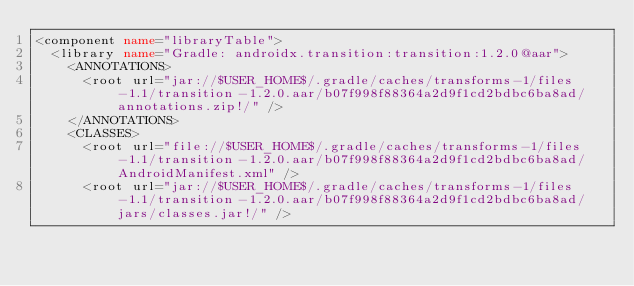<code> <loc_0><loc_0><loc_500><loc_500><_XML_><component name="libraryTable">
  <library name="Gradle: androidx.transition:transition:1.2.0@aar">
    <ANNOTATIONS>
      <root url="jar://$USER_HOME$/.gradle/caches/transforms-1/files-1.1/transition-1.2.0.aar/b07f998f88364a2d9f1cd2bdbc6ba8ad/annotations.zip!/" />
    </ANNOTATIONS>
    <CLASSES>
      <root url="file://$USER_HOME$/.gradle/caches/transforms-1/files-1.1/transition-1.2.0.aar/b07f998f88364a2d9f1cd2bdbc6ba8ad/AndroidManifest.xml" />
      <root url="jar://$USER_HOME$/.gradle/caches/transforms-1/files-1.1/transition-1.2.0.aar/b07f998f88364a2d9f1cd2bdbc6ba8ad/jars/classes.jar!/" /></code> 